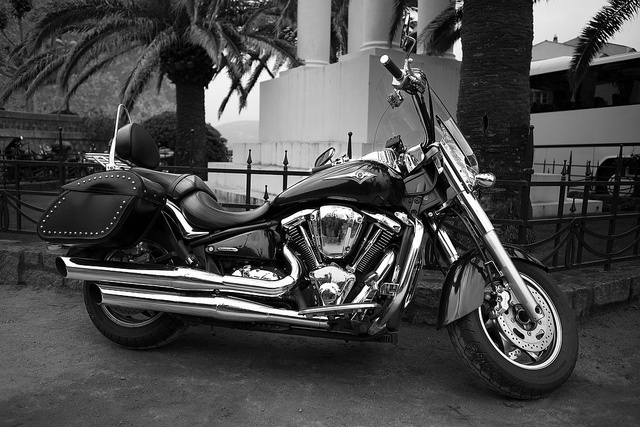Describe the objects in this image and their specific colors. I can see motorcycle in black, gray, white, and darkgray tones and bus in black, gray, and lightgray tones in this image. 